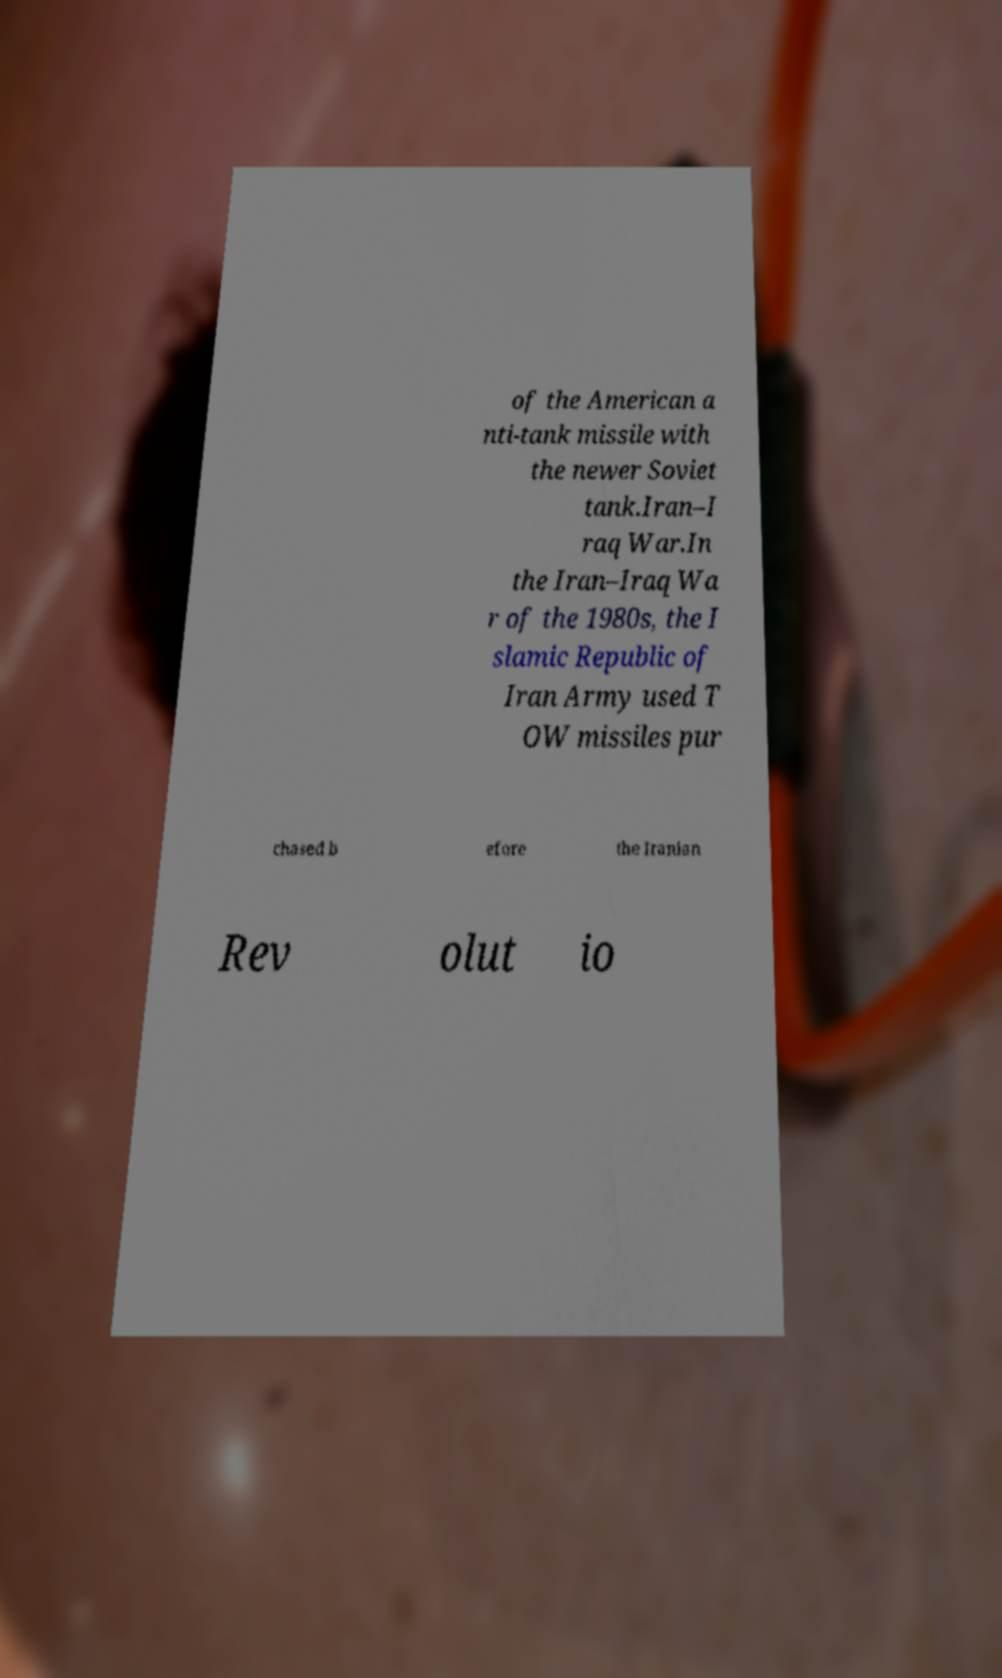What messages or text are displayed in this image? I need them in a readable, typed format. of the American a nti-tank missile with the newer Soviet tank.Iran–I raq War.In the Iran–Iraq Wa r of the 1980s, the I slamic Republic of Iran Army used T OW missiles pur chased b efore the Iranian Rev olut io 